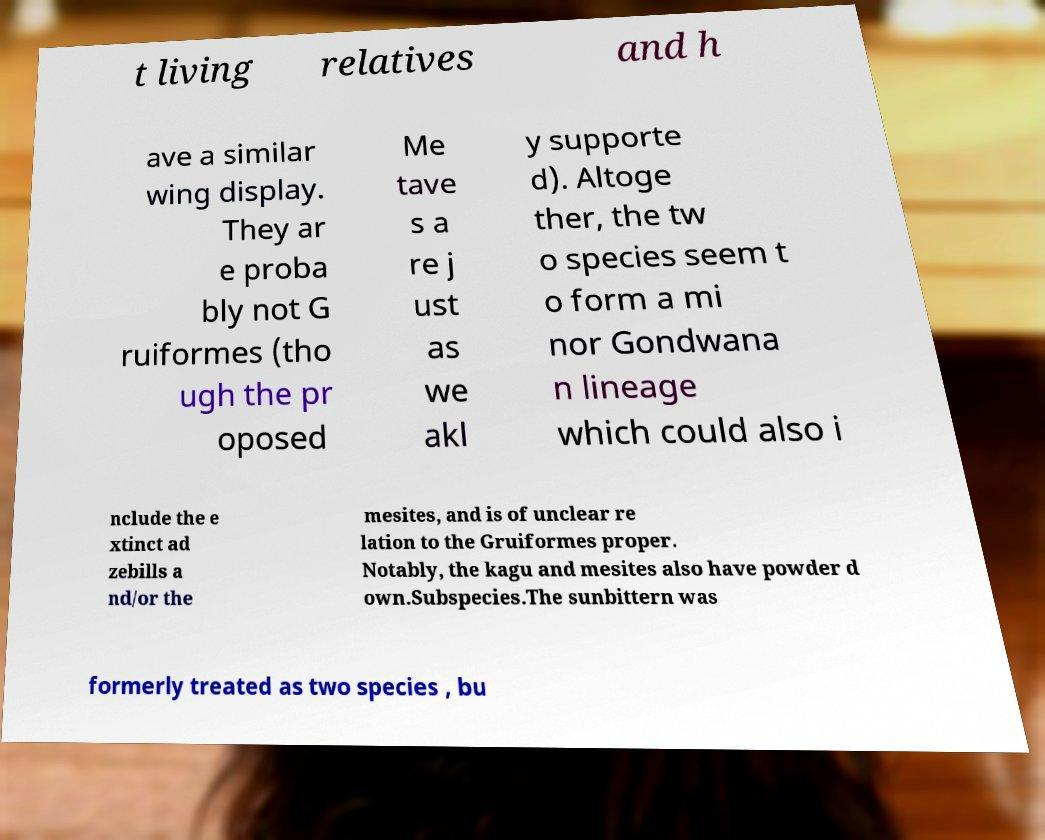Can you accurately transcribe the text from the provided image for me? t living relatives and h ave a similar wing display. They ar e proba bly not G ruiformes (tho ugh the pr oposed Me tave s a re j ust as we akl y supporte d). Altoge ther, the tw o species seem t o form a mi nor Gondwana n lineage which could also i nclude the e xtinct ad zebills a nd/or the mesites, and is of unclear re lation to the Gruiformes proper. Notably, the kagu and mesites also have powder d own.Subspecies.The sunbittern was formerly treated as two species , bu 